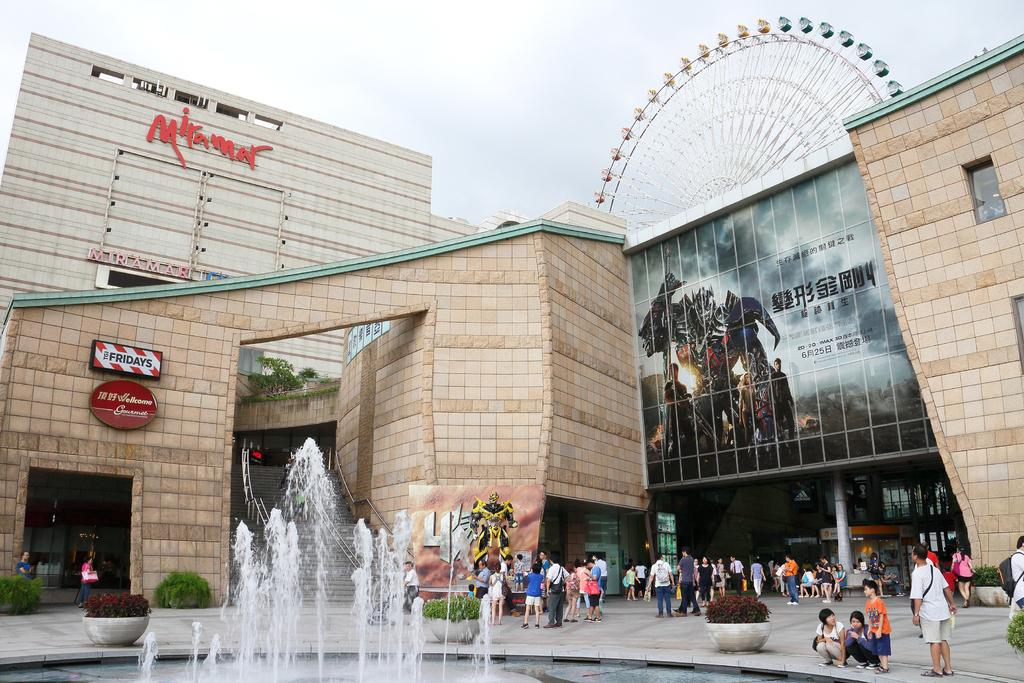What type of structures can be seen in the image? There are buildings in the image. What specific object can be found in the image? A joint wheel is present in the image. What other items are visible in the image? There are boards, plants, a water fountain, and hoardings in the image. Are there any living beings in the image? Yes, people are visible in the image. What can be seen in the background of the image? The sky is visible in the background of the image. What type of riddle is being solved by the plants in the image? There is no riddle being solved by the plants in the image; they are simply visible as part of the scene. How many stitches are required to repair the water fountain in the image? There is no indication that the water fountain needs repairing or requires stitches in the image. 